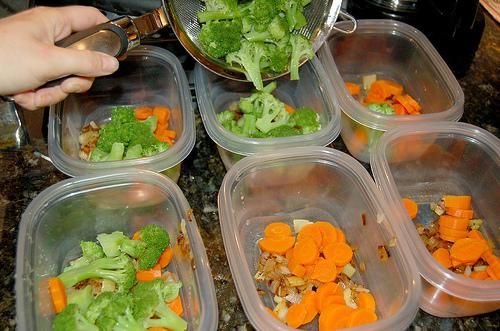How many sliced carrots are on the plate and what is their color? There are multiple sliced carrots on the plate, and they are orange in color. Mention one prominent feature on the surface where the containers are placed. The containers are placed on a marble countertop. Mention the number of containers on the table and their state (empty or filled). There are six containers on the table, all filled with vegetables. Describe the appearance of the strainer and its material. The strainer is made of stainless steel and has a metal loop on it. What types of vegetables are in the containers? Carrots, broccoli, and onions are in the containers. What is inside the strainer held by the person? Cooked broccoli is inside the strainer held by the person. Identify the primary object held by the person in the image. A woman is holding a strainer in the image. What kind of sentiment or emotion can be associated with this image? The image conveys a sense of healthy eating and meal preparation. Briefly describe the scene in the image. A person is draining cooked broccoli in a strainer, with six clear plastic containers filled with mixed vegetables on a marble table. Analyze the interaction between the person and the strainer in the image. The person is holding the strainer to drain the water from the cooked broccoli. 